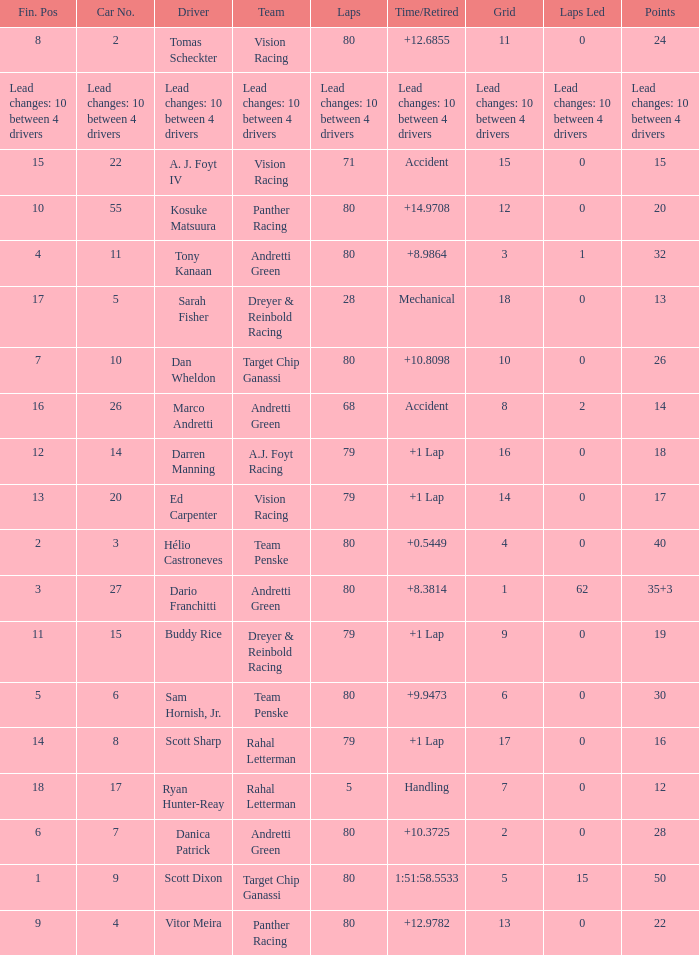How many laps does driver dario franchitti have? 80.0. 